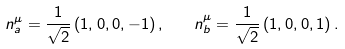<formula> <loc_0><loc_0><loc_500><loc_500>n _ { a } ^ { \mu } = \frac { 1 } { \sqrt { 2 } } \, ( 1 , 0 , 0 , - 1 ) \, , \quad n _ { b } ^ { \mu } = \frac { 1 } { \sqrt { 2 } } \, ( 1 , 0 , 0 , 1 ) \, .</formula> 